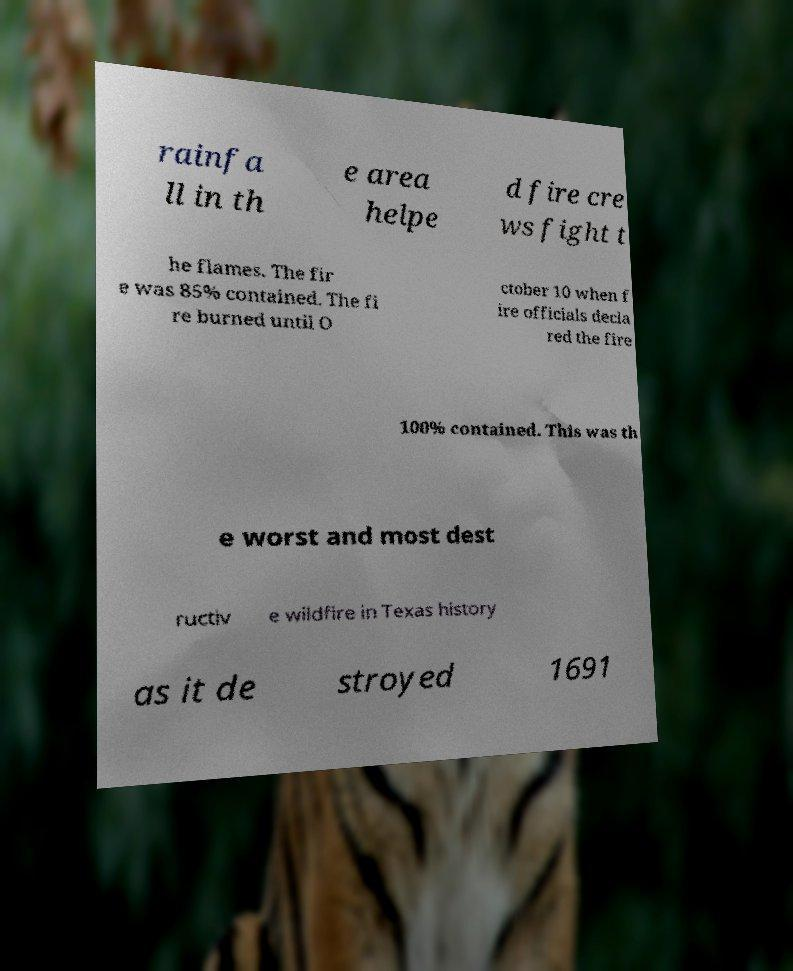Could you assist in decoding the text presented in this image and type it out clearly? rainfa ll in th e area helpe d fire cre ws fight t he flames. The fir e was 85% contained. The fi re burned until O ctober 10 when f ire officials decla red the fire 100% contained. This was th e worst and most dest ructiv e wildfire in Texas history as it de stroyed 1691 